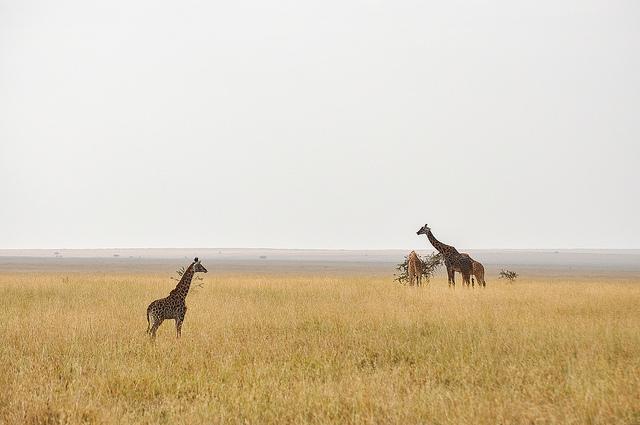Do you see any trees?
Short answer required. No. Is this their natural habitat?
Keep it brief. Yes. What are the animals in the field?
Short answer required. Giraffes. 